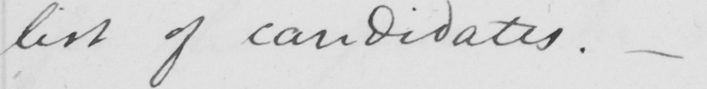What does this handwritten line say? list of candidates . 